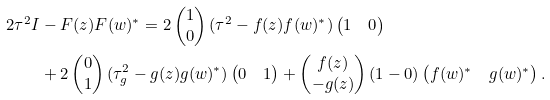Convert formula to latex. <formula><loc_0><loc_0><loc_500><loc_500>2 \tau ^ { 2 } I & - F ( z ) F ( w ) ^ { * } = 2 \begin{pmatrix} 1 \\ 0 \end{pmatrix} ( \tau ^ { 2 } - f ( z ) f ( w ) ^ { * } ) \begin{pmatrix} 1 & 0 \end{pmatrix} \\ & + 2 \begin{pmatrix} 0 \\ 1 \end{pmatrix} ( \tau _ { g } ^ { 2 } - g ( z ) g ( w ) ^ { * } ) \begin{pmatrix} 0 & 1 \end{pmatrix} + \begin{pmatrix} f ( z ) \\ - g ( z ) \end{pmatrix} ( 1 - 0 ) \begin{pmatrix} f ( w ) ^ { * } & g ( w ) ^ { * } \end{pmatrix} .</formula> 